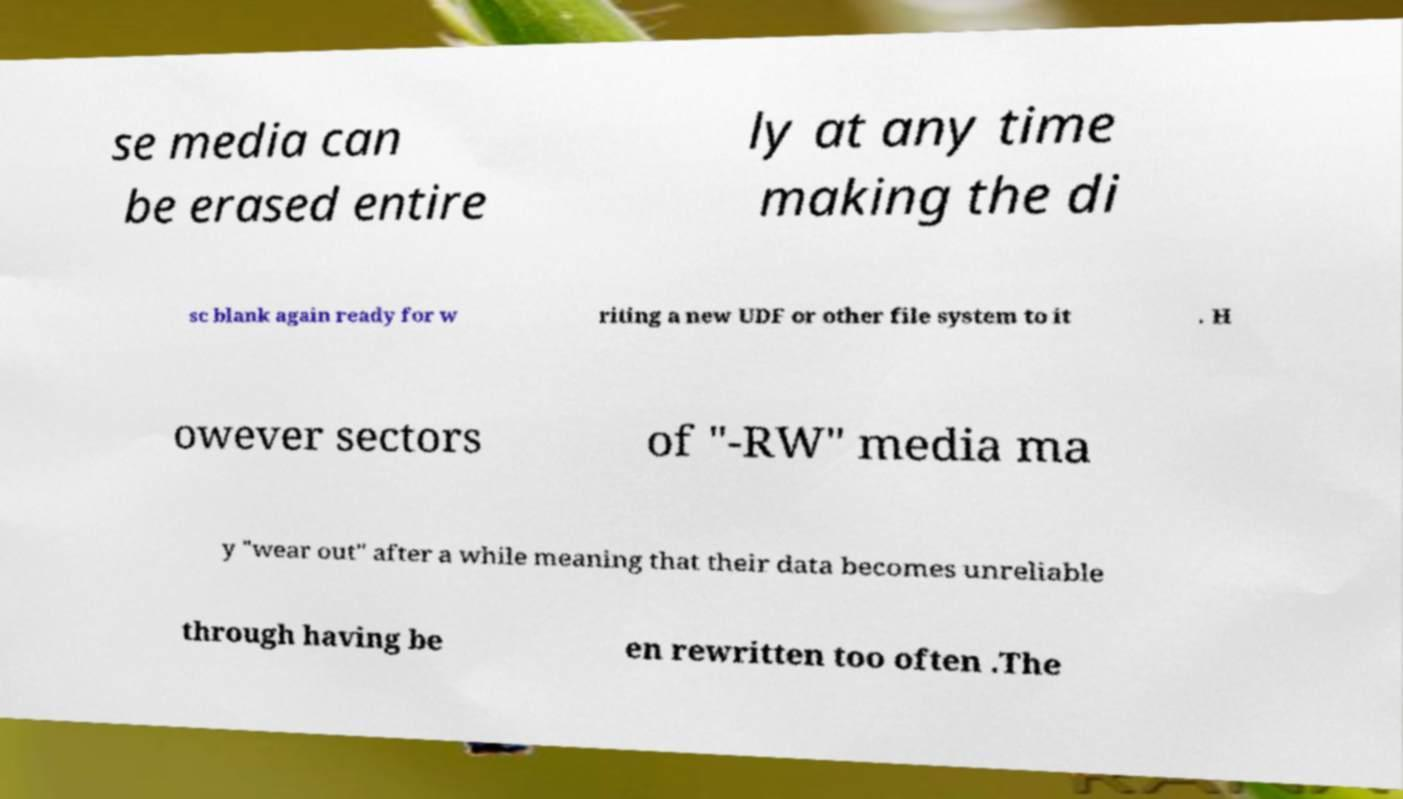Could you assist in decoding the text presented in this image and type it out clearly? se media can be erased entire ly at any time making the di sc blank again ready for w riting a new UDF or other file system to it . H owever sectors of "-RW" media ma y "wear out" after a while meaning that their data becomes unreliable through having be en rewritten too often .The 